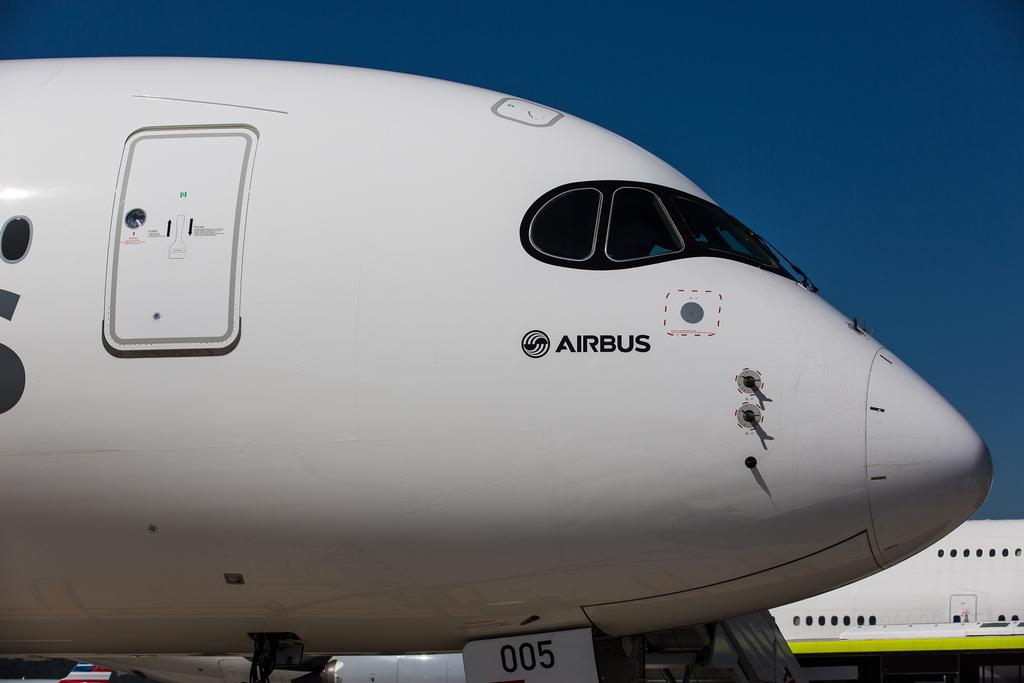Provide a one-sentence caption for the provided image. The type of plane show here is an Airbus. 